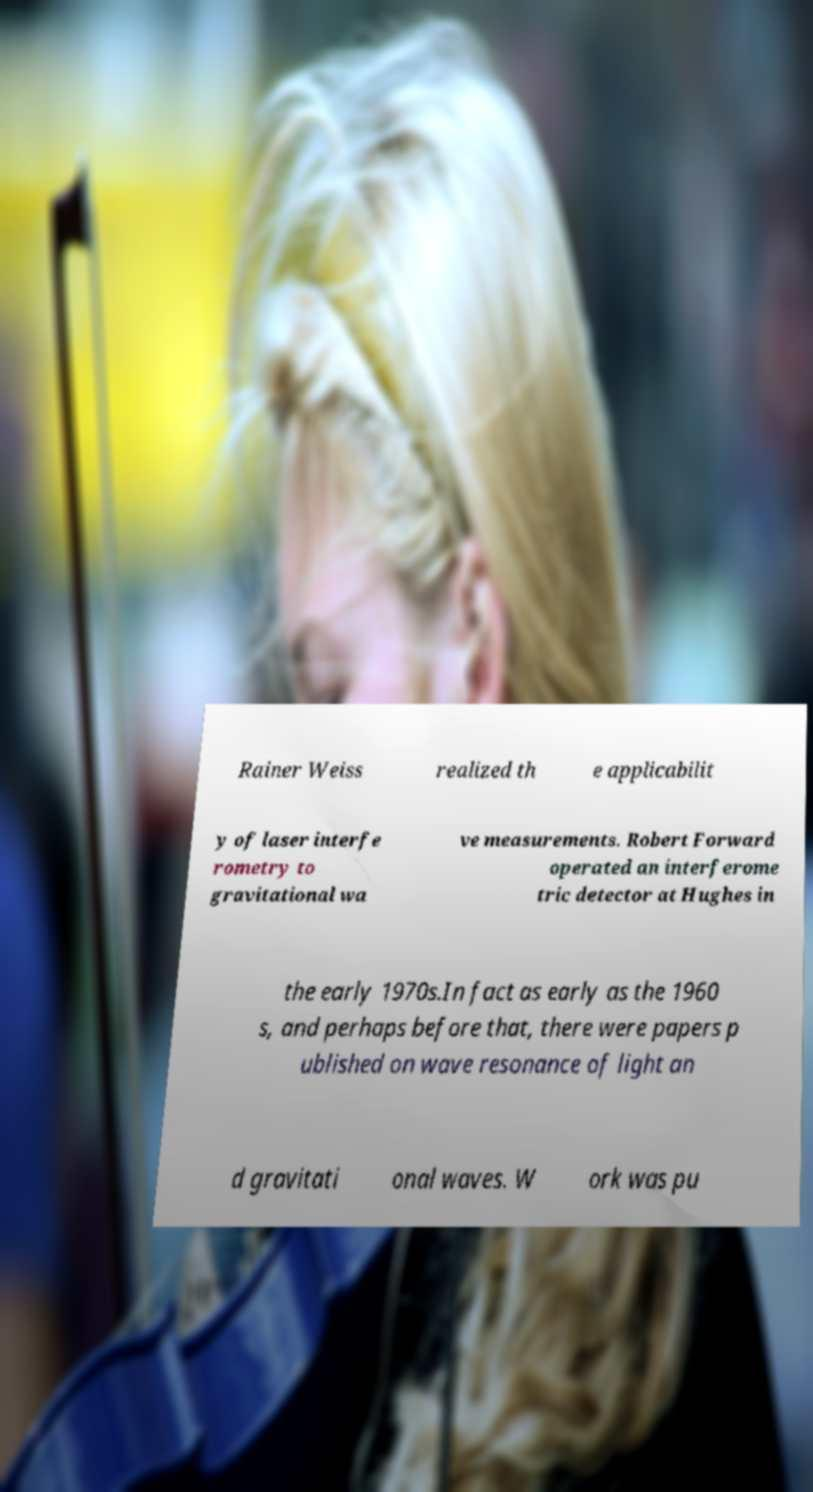Please identify and transcribe the text found in this image. Rainer Weiss realized th e applicabilit y of laser interfe rometry to gravitational wa ve measurements. Robert Forward operated an interferome tric detector at Hughes in the early 1970s.In fact as early as the 1960 s, and perhaps before that, there were papers p ublished on wave resonance of light an d gravitati onal waves. W ork was pu 